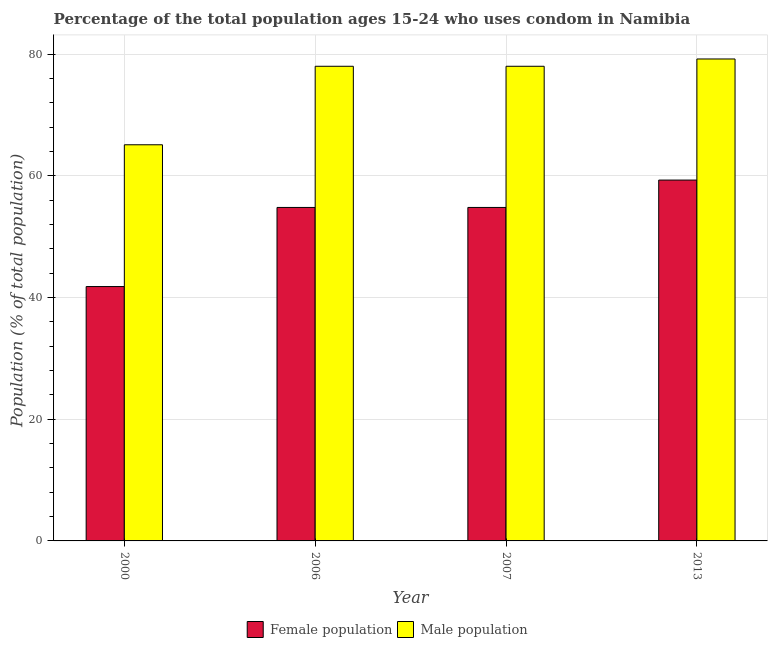How many different coloured bars are there?
Offer a very short reply. 2. Are the number of bars per tick equal to the number of legend labels?
Provide a short and direct response. Yes. How many bars are there on the 2nd tick from the left?
Your answer should be compact. 2. How many bars are there on the 2nd tick from the right?
Offer a very short reply. 2. In how many cases, is the number of bars for a given year not equal to the number of legend labels?
Your answer should be very brief. 0. What is the male population in 2013?
Keep it short and to the point. 79.2. Across all years, what is the maximum male population?
Offer a very short reply. 79.2. Across all years, what is the minimum male population?
Make the answer very short. 65.1. In which year was the male population maximum?
Keep it short and to the point. 2013. In which year was the male population minimum?
Provide a succinct answer. 2000. What is the total female population in the graph?
Offer a very short reply. 210.7. What is the difference between the female population in 2006 and that in 2013?
Provide a short and direct response. -4.5. What is the average female population per year?
Give a very brief answer. 52.67. In the year 2007, what is the difference between the male population and female population?
Provide a short and direct response. 0. What is the ratio of the male population in 2000 to that in 2013?
Your answer should be compact. 0.82. Is the female population in 2006 less than that in 2007?
Give a very brief answer. No. What is the difference between the highest and the second highest female population?
Your response must be concise. 4.5. What is the difference between the highest and the lowest female population?
Provide a short and direct response. 17.5. In how many years, is the female population greater than the average female population taken over all years?
Make the answer very short. 3. What does the 1st bar from the left in 2000 represents?
Give a very brief answer. Female population. What does the 2nd bar from the right in 2006 represents?
Keep it short and to the point. Female population. What is the difference between two consecutive major ticks on the Y-axis?
Make the answer very short. 20. Does the graph contain any zero values?
Your answer should be very brief. No. Where does the legend appear in the graph?
Your response must be concise. Bottom center. What is the title of the graph?
Give a very brief answer. Percentage of the total population ages 15-24 who uses condom in Namibia. Does "Overweight" appear as one of the legend labels in the graph?
Give a very brief answer. No. What is the label or title of the X-axis?
Your answer should be very brief. Year. What is the label or title of the Y-axis?
Offer a very short reply. Population (% of total population) . What is the Population (% of total population)  of Female population in 2000?
Your answer should be compact. 41.8. What is the Population (% of total population)  in Male population in 2000?
Your response must be concise. 65.1. What is the Population (% of total population)  in Female population in 2006?
Give a very brief answer. 54.8. What is the Population (% of total population)  of Female population in 2007?
Give a very brief answer. 54.8. What is the Population (% of total population)  in Male population in 2007?
Your answer should be compact. 78. What is the Population (% of total population)  in Female population in 2013?
Provide a short and direct response. 59.3. What is the Population (% of total population)  in Male population in 2013?
Provide a short and direct response. 79.2. Across all years, what is the maximum Population (% of total population)  of Female population?
Your answer should be very brief. 59.3. Across all years, what is the maximum Population (% of total population)  in Male population?
Make the answer very short. 79.2. Across all years, what is the minimum Population (% of total population)  in Female population?
Offer a terse response. 41.8. Across all years, what is the minimum Population (% of total population)  of Male population?
Give a very brief answer. 65.1. What is the total Population (% of total population)  of Female population in the graph?
Your answer should be compact. 210.7. What is the total Population (% of total population)  of Male population in the graph?
Offer a terse response. 300.3. What is the difference between the Population (% of total population)  in Female population in 2000 and that in 2013?
Ensure brevity in your answer.  -17.5. What is the difference between the Population (% of total population)  in Male population in 2000 and that in 2013?
Offer a terse response. -14.1. What is the difference between the Population (% of total population)  in Female population in 2006 and that in 2007?
Give a very brief answer. 0. What is the difference between the Population (% of total population)  of Female population in 2006 and that in 2013?
Your answer should be very brief. -4.5. What is the difference between the Population (% of total population)  in Female population in 2007 and that in 2013?
Ensure brevity in your answer.  -4.5. What is the difference between the Population (% of total population)  of Male population in 2007 and that in 2013?
Ensure brevity in your answer.  -1.2. What is the difference between the Population (% of total population)  in Female population in 2000 and the Population (% of total population)  in Male population in 2006?
Your answer should be compact. -36.2. What is the difference between the Population (% of total population)  in Female population in 2000 and the Population (% of total population)  in Male population in 2007?
Keep it short and to the point. -36.2. What is the difference between the Population (% of total population)  in Female population in 2000 and the Population (% of total population)  in Male population in 2013?
Your answer should be very brief. -37.4. What is the difference between the Population (% of total population)  in Female population in 2006 and the Population (% of total population)  in Male population in 2007?
Your answer should be compact. -23.2. What is the difference between the Population (% of total population)  in Female population in 2006 and the Population (% of total population)  in Male population in 2013?
Your response must be concise. -24.4. What is the difference between the Population (% of total population)  in Female population in 2007 and the Population (% of total population)  in Male population in 2013?
Your answer should be very brief. -24.4. What is the average Population (% of total population)  of Female population per year?
Keep it short and to the point. 52.67. What is the average Population (% of total population)  of Male population per year?
Keep it short and to the point. 75.08. In the year 2000, what is the difference between the Population (% of total population)  in Female population and Population (% of total population)  in Male population?
Provide a short and direct response. -23.3. In the year 2006, what is the difference between the Population (% of total population)  of Female population and Population (% of total population)  of Male population?
Provide a short and direct response. -23.2. In the year 2007, what is the difference between the Population (% of total population)  in Female population and Population (% of total population)  in Male population?
Provide a succinct answer. -23.2. In the year 2013, what is the difference between the Population (% of total population)  in Female population and Population (% of total population)  in Male population?
Offer a terse response. -19.9. What is the ratio of the Population (% of total population)  in Female population in 2000 to that in 2006?
Provide a succinct answer. 0.76. What is the ratio of the Population (% of total population)  of Male population in 2000 to that in 2006?
Ensure brevity in your answer.  0.83. What is the ratio of the Population (% of total population)  of Female population in 2000 to that in 2007?
Keep it short and to the point. 0.76. What is the ratio of the Population (% of total population)  in Male population in 2000 to that in 2007?
Give a very brief answer. 0.83. What is the ratio of the Population (% of total population)  of Female population in 2000 to that in 2013?
Your answer should be very brief. 0.7. What is the ratio of the Population (% of total population)  of Male population in 2000 to that in 2013?
Offer a very short reply. 0.82. What is the ratio of the Population (% of total population)  of Female population in 2006 to that in 2007?
Your answer should be compact. 1. What is the ratio of the Population (% of total population)  of Female population in 2006 to that in 2013?
Offer a very short reply. 0.92. What is the ratio of the Population (% of total population)  of Male population in 2006 to that in 2013?
Make the answer very short. 0.98. What is the ratio of the Population (% of total population)  in Female population in 2007 to that in 2013?
Ensure brevity in your answer.  0.92. What is the ratio of the Population (% of total population)  of Male population in 2007 to that in 2013?
Ensure brevity in your answer.  0.98. What is the difference between the highest and the second highest Population (% of total population)  in Female population?
Your answer should be compact. 4.5. What is the difference between the highest and the lowest Population (% of total population)  of Female population?
Your answer should be very brief. 17.5. 